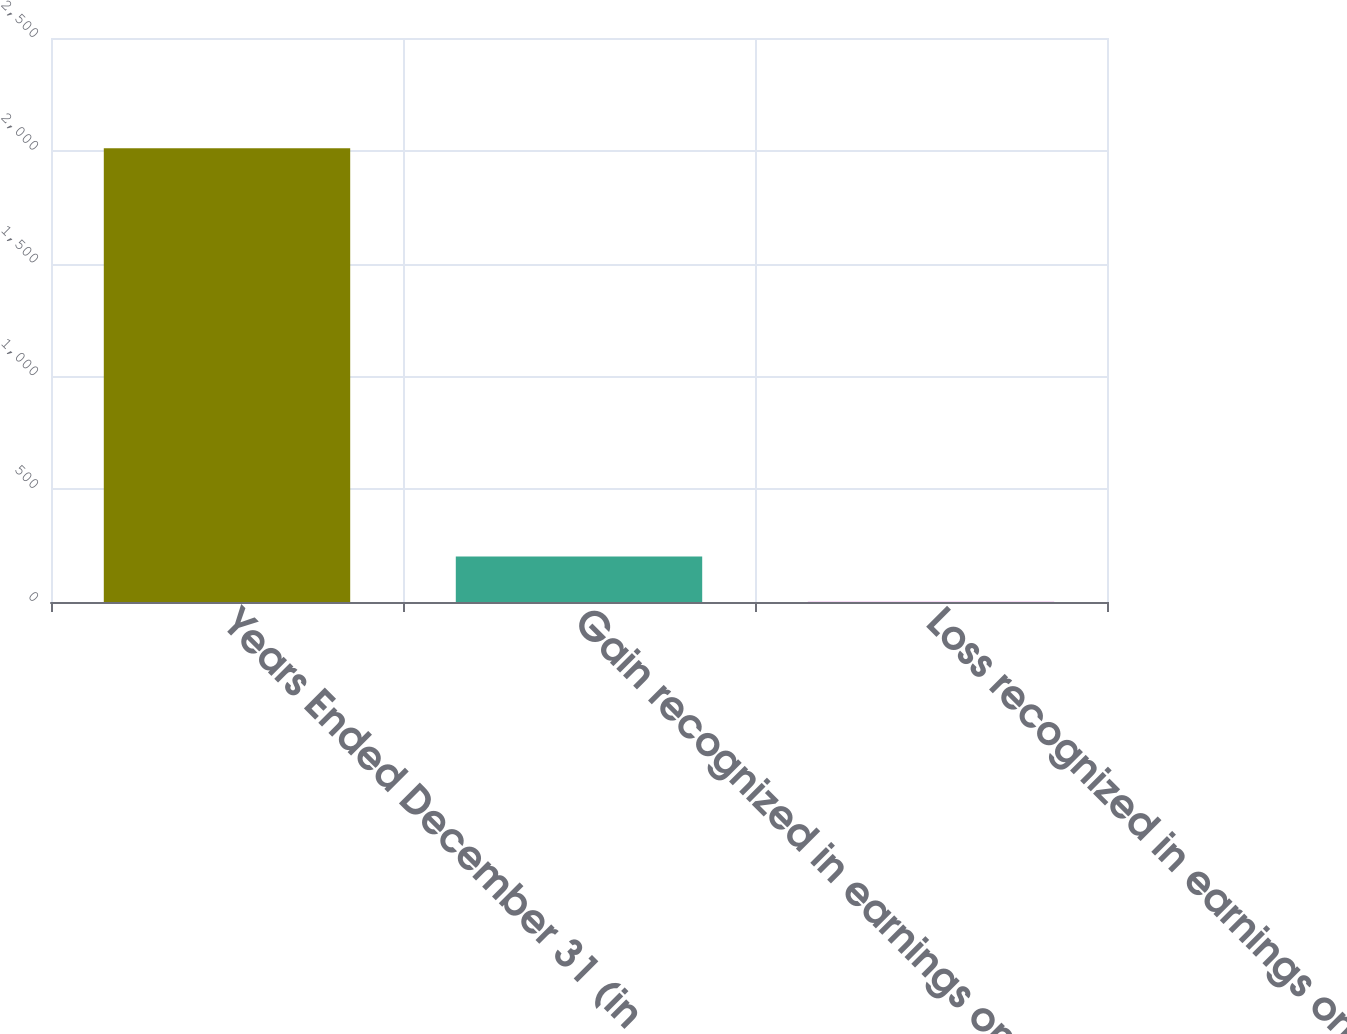Convert chart to OTSL. <chart><loc_0><loc_0><loc_500><loc_500><bar_chart><fcel>Years Ended December 31 (in<fcel>Gain recognized in earnings on<fcel>Loss recognized in earnings on<nl><fcel>2011<fcel>202<fcel>1<nl></chart> 